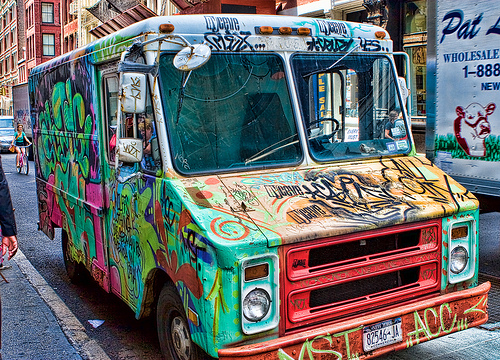<image>
Can you confirm if the van is on the road? Yes. Looking at the image, I can see the van is positioned on top of the road, with the road providing support. 